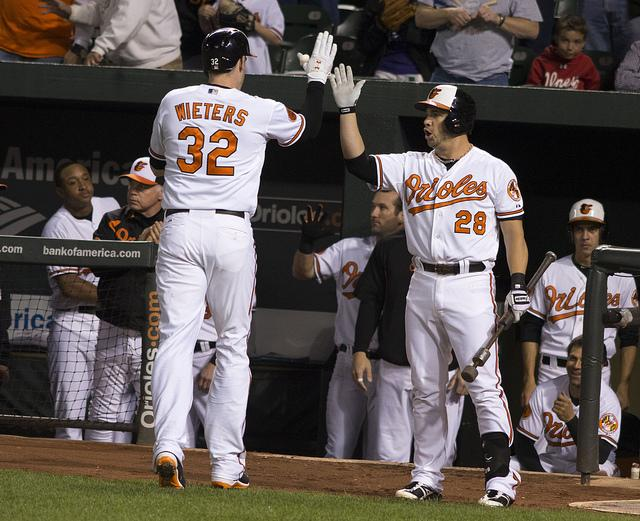What are the players here likely celebrating? Please explain your reasoning. homerun. The players are high fiving each other. 